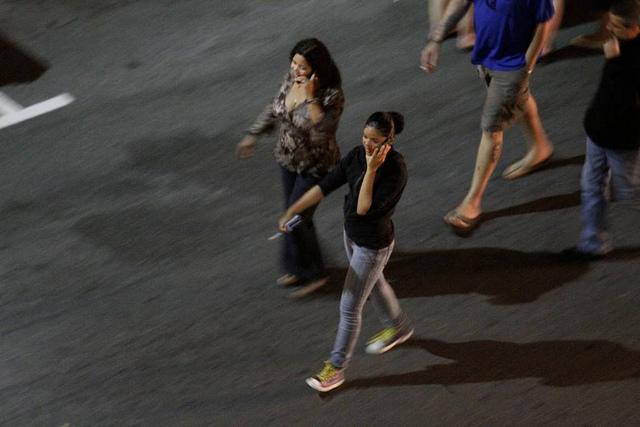What are these women doing?
Write a very short answer. Walking. Is she calling or sending a text message?
Quick response, please. Calling. What do the people have in their hands?
Answer briefly. Phones. How many people in the photo?
Write a very short answer. 4. What color are the lead walker's shoelaces?
Quick response, please. Yellow. Are they playing a sport?
Quick response, please. No. 